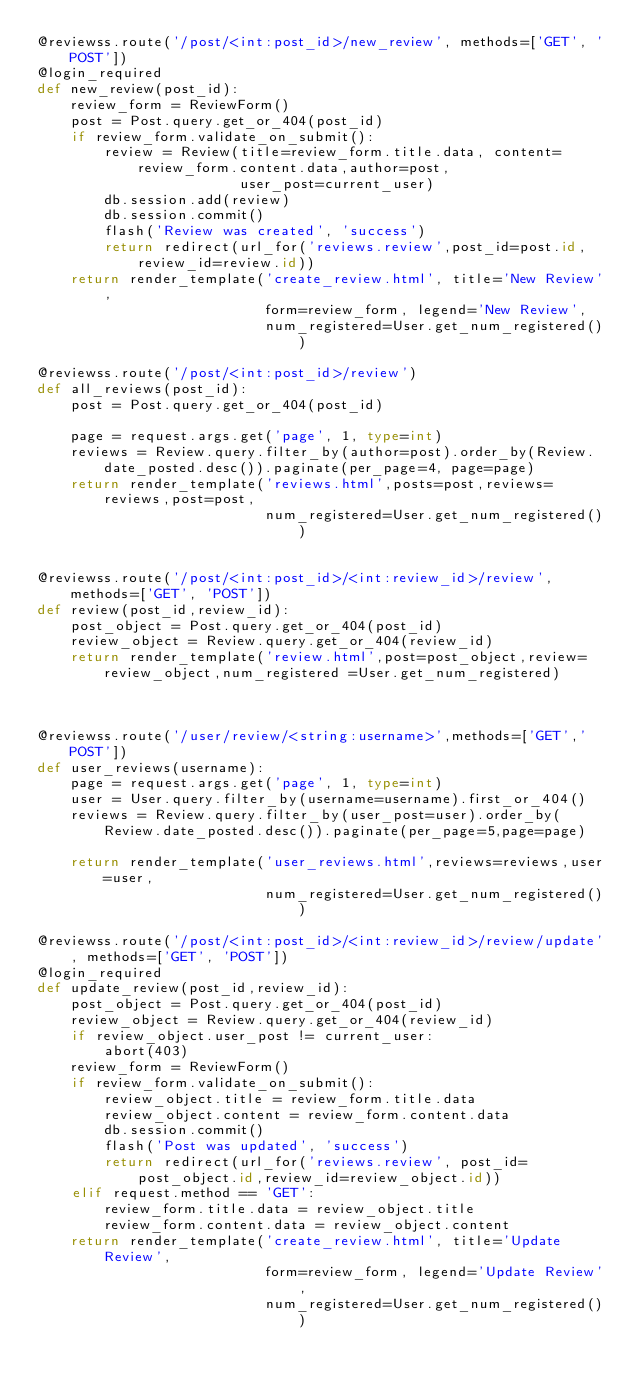Convert code to text. <code><loc_0><loc_0><loc_500><loc_500><_Python_>@reviewss.route('/post/<int:post_id>/new_review', methods=['GET', 'POST'])
@login_required
def new_review(post_id):
    review_form = ReviewForm()
    post = Post.query.get_or_404(post_id)
    if review_form.validate_on_submit():
        review = Review(title=review_form.title.data, content=review_form.content.data,author=post,
                        user_post=current_user)
        db.session.add(review)
        db.session.commit()
        flash('Review was created', 'success')
        return redirect(url_for('reviews.review',post_id=post.id,review_id=review.id))
    return render_template('create_review.html', title='New Review',
                           form=review_form, legend='New Review',
                           num_registered=User.get_num_registered())

@reviewss.route('/post/<int:post_id>/review')
def all_reviews(post_id):
    post = Post.query.get_or_404(post_id)

    page = request.args.get('page', 1, type=int)
    reviews = Review.query.filter_by(author=post).order_by(Review.date_posted.desc()).paginate(per_page=4, page=page)
    return render_template('reviews.html',posts=post,reviews=reviews,post=post,
                           num_registered=User.get_num_registered())


@reviewss.route('/post/<int:post_id>/<int:review_id>/review', methods=['GET', 'POST'])
def review(post_id,review_id):
    post_object = Post.query.get_or_404(post_id)
    review_object = Review.query.get_or_404(review_id)
    return render_template('review.html',post=post_object,review=review_object,num_registered =User.get_num_registered)
    


@reviewss.route('/user/review/<string:username>',methods=['GET','POST'])
def user_reviews(username):
    page = request.args.get('page', 1, type=int)
    user = User.query.filter_by(username=username).first_or_404()
    reviews = Review.query.filter_by(user_post=user).order_by(Review.date_posted.desc()).paginate(per_page=5,page=page)
    
    return render_template('user_reviews.html',reviews=reviews,user=user,
                           num_registered=User.get_num_registered())

@reviewss.route('/post/<int:post_id>/<int:review_id>/review/update', methods=['GET', 'POST'])
@login_required
def update_review(post_id,review_id):
    post_object = Post.query.get_or_404(post_id)
    review_object = Review.query.get_or_404(review_id)
    if review_object.user_post != current_user:
        abort(403)
    review_form = ReviewForm()
    if review_form.validate_on_submit():
        review_object.title = review_form.title.data
        review_object.content = review_form.content.data
        db.session.commit()
        flash('Post was updated', 'success')
        return redirect(url_for('reviews.review', post_id=post_object.id,review_id=review_object.id))
    elif request.method == 'GET':
        review_form.title.data = review_object.title
        review_form.content.data = review_object.content
    return render_template('create_review.html', title='Update Review',
                           form=review_form, legend='Update Review',
                           num_registered=User.get_num_registered())


</code> 